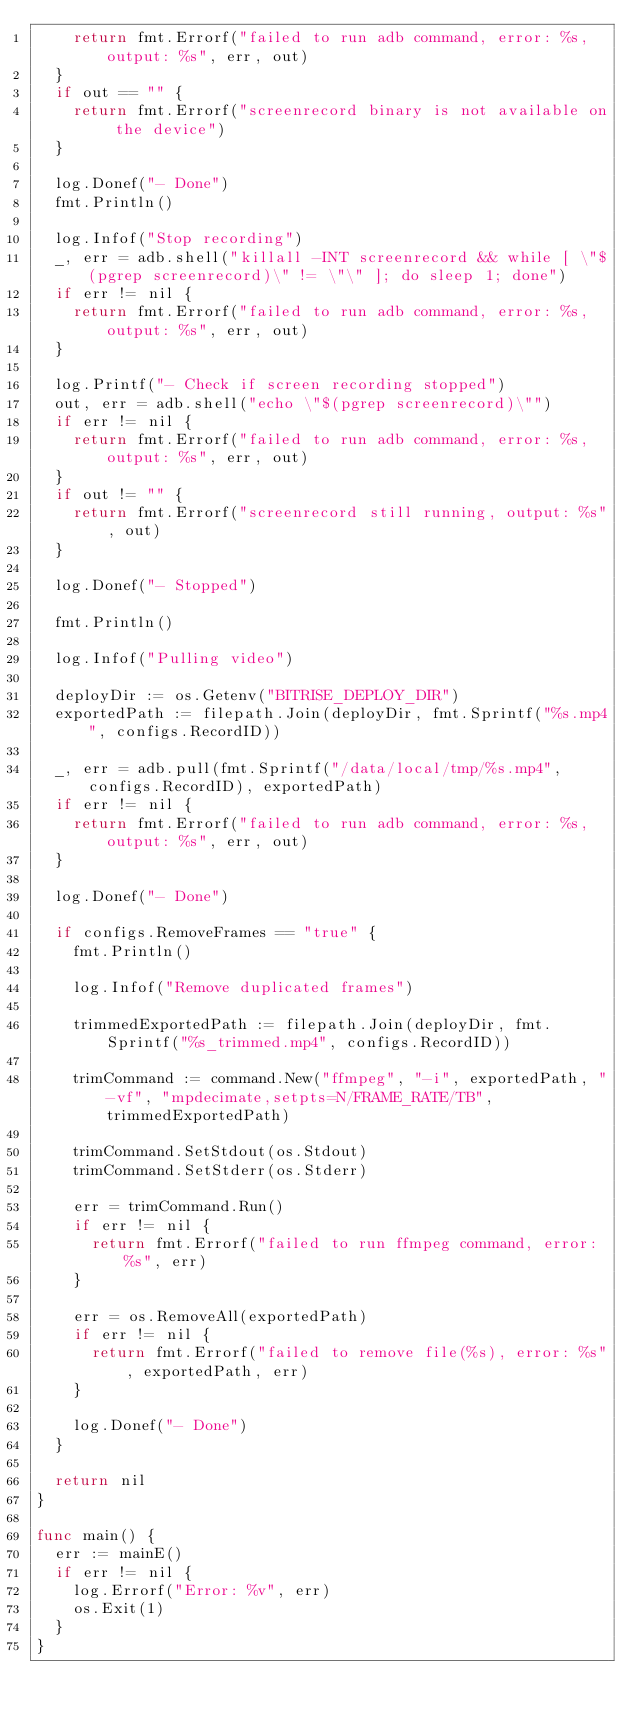Convert code to text. <code><loc_0><loc_0><loc_500><loc_500><_Go_>		return fmt.Errorf("failed to run adb command, error: %s, output: %s", err, out)
	}
	if out == "" {
		return fmt.Errorf("screenrecord binary is not available on the device")
	}

	log.Donef("- Done")
	fmt.Println()

	log.Infof("Stop recording")
	_, err = adb.shell("killall -INT screenrecord && while [ \"$(pgrep screenrecord)\" != \"\" ]; do sleep 1; done")
	if err != nil {
		return fmt.Errorf("failed to run adb command, error: %s, output: %s", err, out)
	}

	log.Printf("- Check if screen recording stopped")
	out, err = adb.shell("echo \"$(pgrep screenrecord)\"")
	if err != nil {
		return fmt.Errorf("failed to run adb command, error: %s, output: %s", err, out)
	}
	if out != "" {
		return fmt.Errorf("screenrecord still running, output: %s", out)
	}

	log.Donef("- Stopped")

	fmt.Println()

	log.Infof("Pulling video")

	deployDir := os.Getenv("BITRISE_DEPLOY_DIR")
	exportedPath := filepath.Join(deployDir, fmt.Sprintf("%s.mp4", configs.RecordID))

	_, err = adb.pull(fmt.Sprintf("/data/local/tmp/%s.mp4", configs.RecordID), exportedPath)
	if err != nil {
		return fmt.Errorf("failed to run adb command, error: %s, output: %s", err, out)
	}

	log.Donef("- Done")

	if configs.RemoveFrames == "true" {
		fmt.Println()

		log.Infof("Remove duplicated frames")

		trimmedExportedPath := filepath.Join(deployDir, fmt.Sprintf("%s_trimmed.mp4", configs.RecordID))

		trimCommand := command.New("ffmpeg", "-i", exportedPath, "-vf", "mpdecimate,setpts=N/FRAME_RATE/TB", trimmedExportedPath)

		trimCommand.SetStdout(os.Stdout)
		trimCommand.SetStderr(os.Stderr)

		err = trimCommand.Run()
		if err != nil {
			return fmt.Errorf("failed to run ffmpeg command, error: %s", err)
		}

		err = os.RemoveAll(exportedPath)
		if err != nil {
			return fmt.Errorf("failed to remove file(%s), error: %s", exportedPath, err)
		}

		log.Donef("- Done")
	}

	return nil
}

func main() {
	err := mainE()
	if err != nil {
		log.Errorf("Error: %v", err)
		os.Exit(1)
	}
}
</code> 